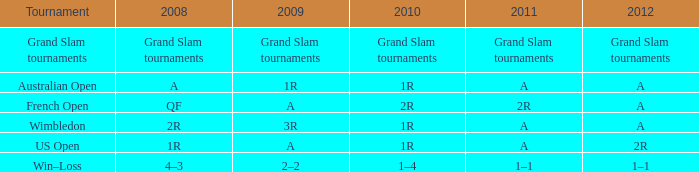Name the tournament when it has 2011 of 2r French Open. 